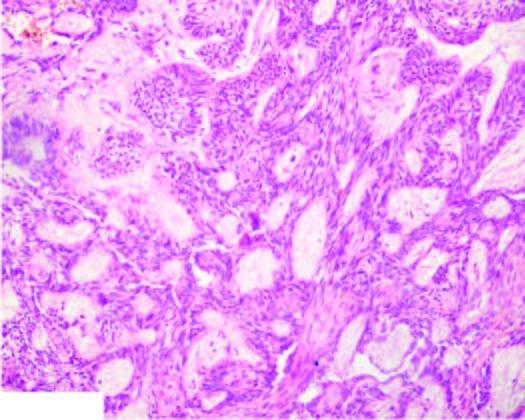do a few areas show central cystic change?
Answer the question using a single word or phrase. Yes 